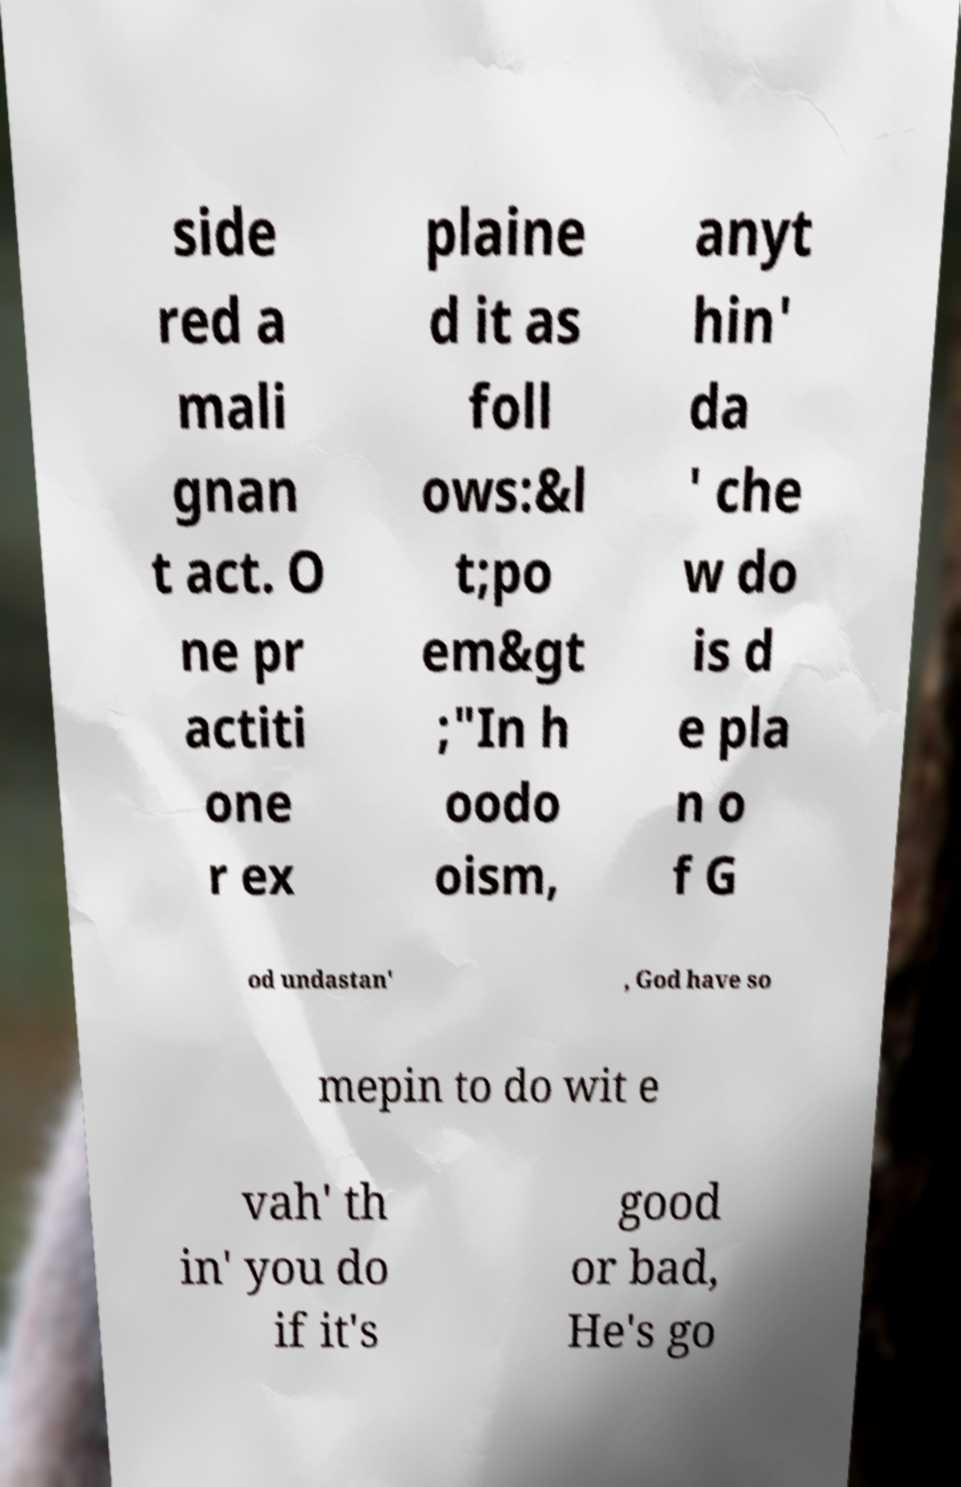Can you read and provide the text displayed in the image?This photo seems to have some interesting text. Can you extract and type it out for me? side red a mali gnan t act. O ne pr actiti one r ex plaine d it as foll ows:&l t;po em&gt ;"In h oodo oism, anyt hin' da ' che w do is d e pla n o f G od undastan' , God have so mepin to do wit e vah' th in' you do if it's good or bad, He's go 